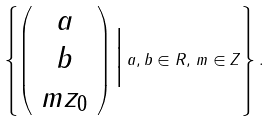Convert formula to latex. <formula><loc_0><loc_0><loc_500><loc_500>\left \{ \left ( \begin{array} { c } { a } \\ { b } \\ { m z _ { 0 } } \end{array} \right ) \Big | \, a , b \in { R } , \, m \in { Z } \right \} .</formula> 